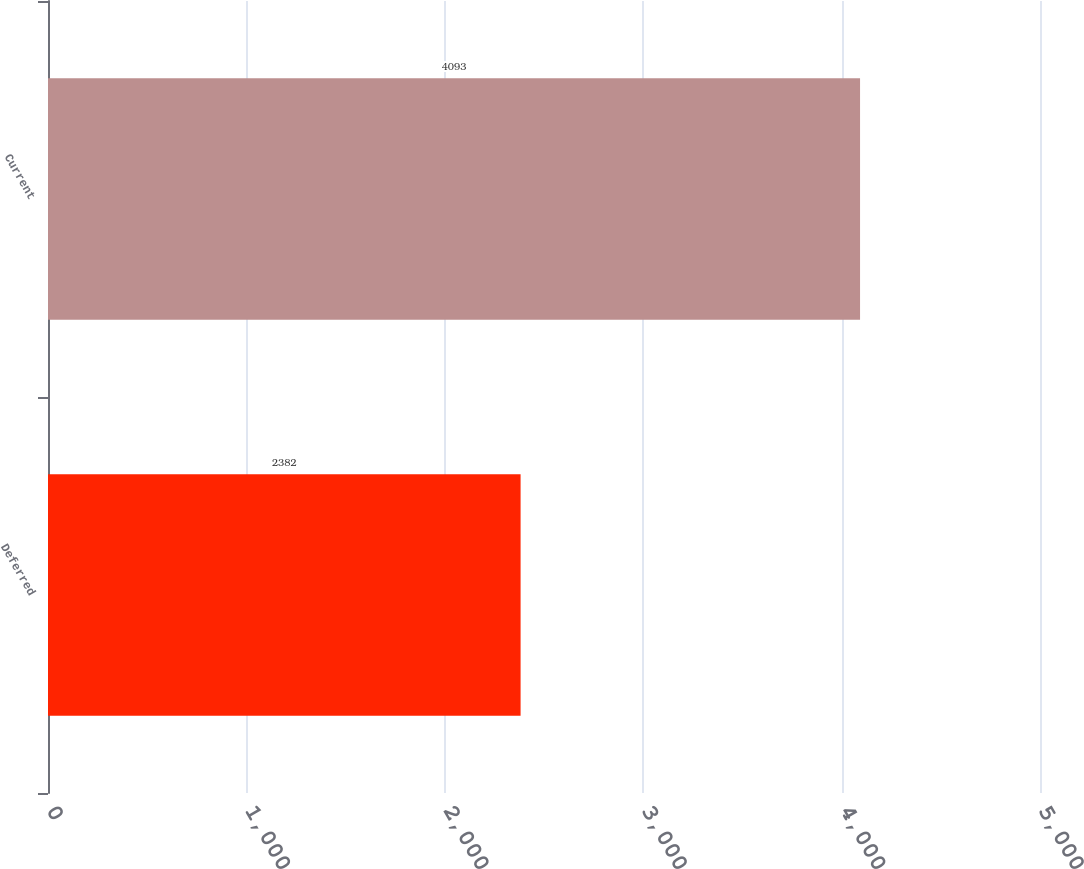Convert chart to OTSL. <chart><loc_0><loc_0><loc_500><loc_500><bar_chart><fcel>Deferred<fcel>Current<nl><fcel>2382<fcel>4093<nl></chart> 